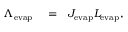Convert formula to latex. <formula><loc_0><loc_0><loc_500><loc_500>\begin{array} { r l r } { \Lambda _ { e v a p } } & = } & { J _ { e v a p } L _ { e v a p } , } \end{array}</formula> 